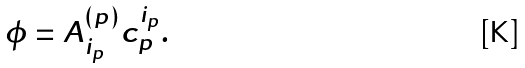Convert formula to latex. <formula><loc_0><loc_0><loc_500><loc_500>\phi = A ^ { ( p ) } _ { i _ { p } } c _ { p } ^ { i _ { p } } .</formula> 